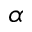Convert formula to latex. <formula><loc_0><loc_0><loc_500><loc_500>\alpha</formula> 